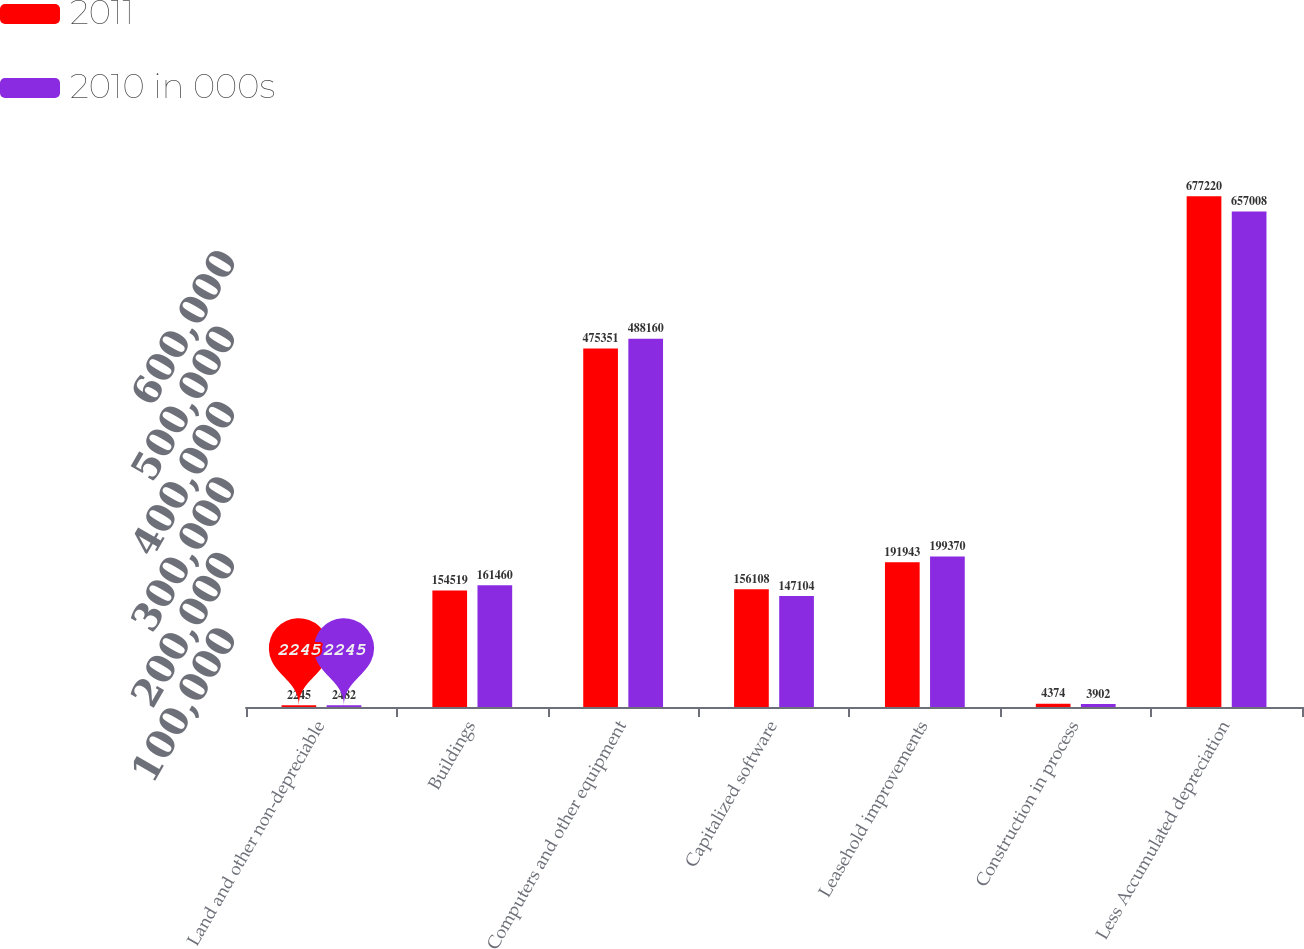Convert chart. <chart><loc_0><loc_0><loc_500><loc_500><stacked_bar_chart><ecel><fcel>Land and other non-depreciable<fcel>Buildings<fcel>Computers and other equipment<fcel>Capitalized software<fcel>Leasehold improvements<fcel>Construction in process<fcel>Less Accumulated depreciation<nl><fcel>2011<fcel>2245<fcel>154519<fcel>475351<fcel>156108<fcel>191943<fcel>4374<fcel>677220<nl><fcel>2010 in 000s<fcel>2482<fcel>161460<fcel>488160<fcel>147104<fcel>199370<fcel>3902<fcel>657008<nl></chart> 